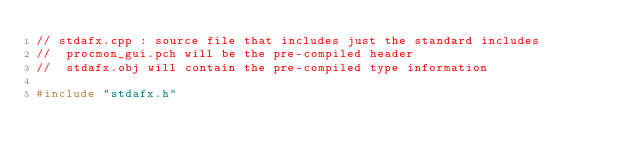Convert code to text. <code><loc_0><loc_0><loc_500><loc_500><_C++_>// stdafx.cpp : source file that includes just the standard includes
//	procmon_gui.pch will be the pre-compiled header
//	stdafx.obj will contain the pre-compiled type information

#include "stdafx.h"
</code> 